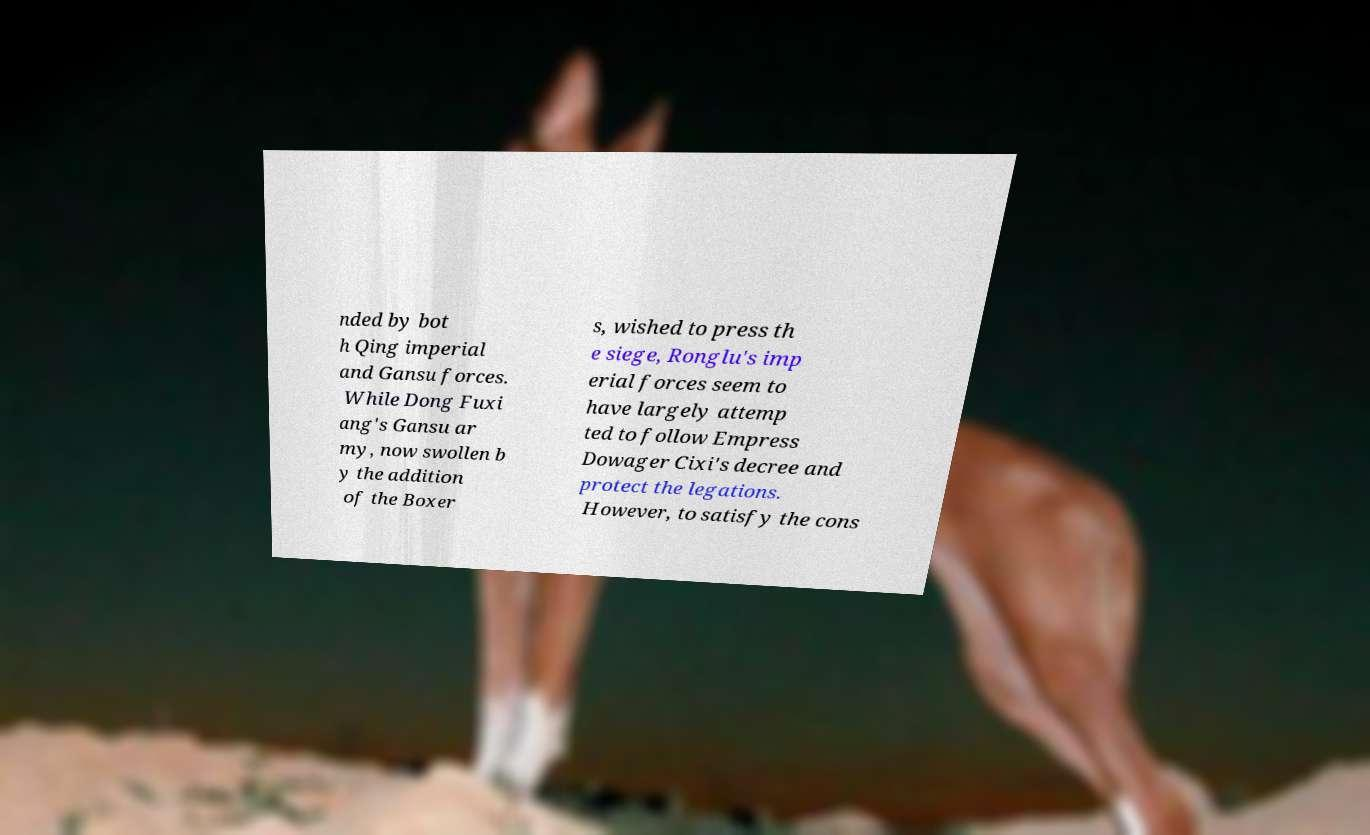Could you assist in decoding the text presented in this image and type it out clearly? nded by bot h Qing imperial and Gansu forces. While Dong Fuxi ang's Gansu ar my, now swollen b y the addition of the Boxer s, wished to press th e siege, Ronglu's imp erial forces seem to have largely attemp ted to follow Empress Dowager Cixi's decree and protect the legations. However, to satisfy the cons 